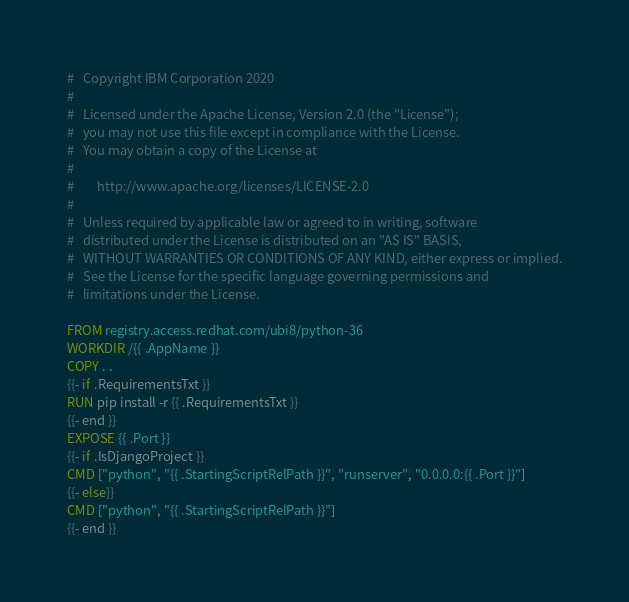Convert code to text. <code><loc_0><loc_0><loc_500><loc_500><_Dockerfile_>#   Copyright IBM Corporation 2020
#
#   Licensed under the Apache License, Version 2.0 (the "License");
#   you may not use this file except in compliance with the License.
#   You may obtain a copy of the License at
#
#        http://www.apache.org/licenses/LICENSE-2.0
#
#   Unless required by applicable law or agreed to in writing, software
#   distributed under the License is distributed on an "AS IS" BASIS,
#   WITHOUT WARRANTIES OR CONDITIONS OF ANY KIND, either express or implied.
#   See the License for the specific language governing permissions and
#   limitations under the License.

FROM registry.access.redhat.com/ubi8/python-36
WORKDIR /{{ .AppName }}
COPY . .
{{- if .RequirementsTxt }}
RUN pip install -r {{ .RequirementsTxt }}
{{- end }}
EXPOSE {{ .Port }}
{{- if .IsDjangoProject }}
CMD ["python", "{{ .StartingScriptRelPath }}", "runserver", "0.0.0.0:{{ .Port }}"]
{{- else}}
CMD ["python", "{{ .StartingScriptRelPath }}"]
{{- end }}
</code> 